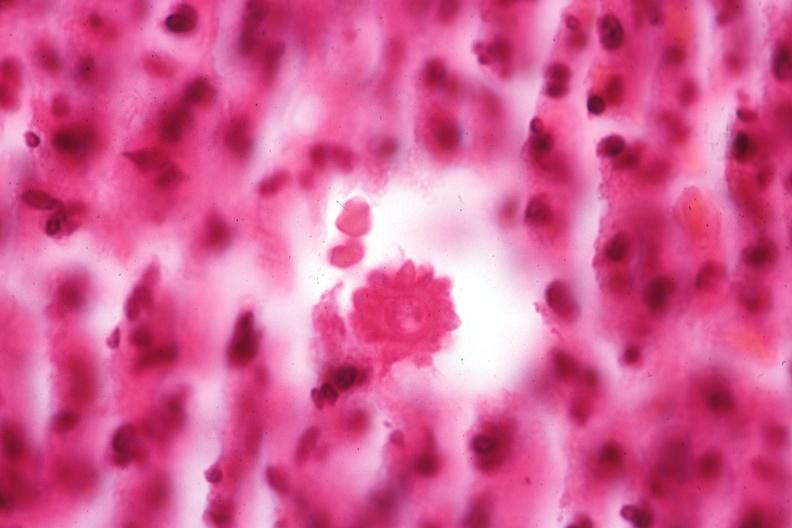what is present?
Answer the question using a single word or phrase. Sporotrichosis 